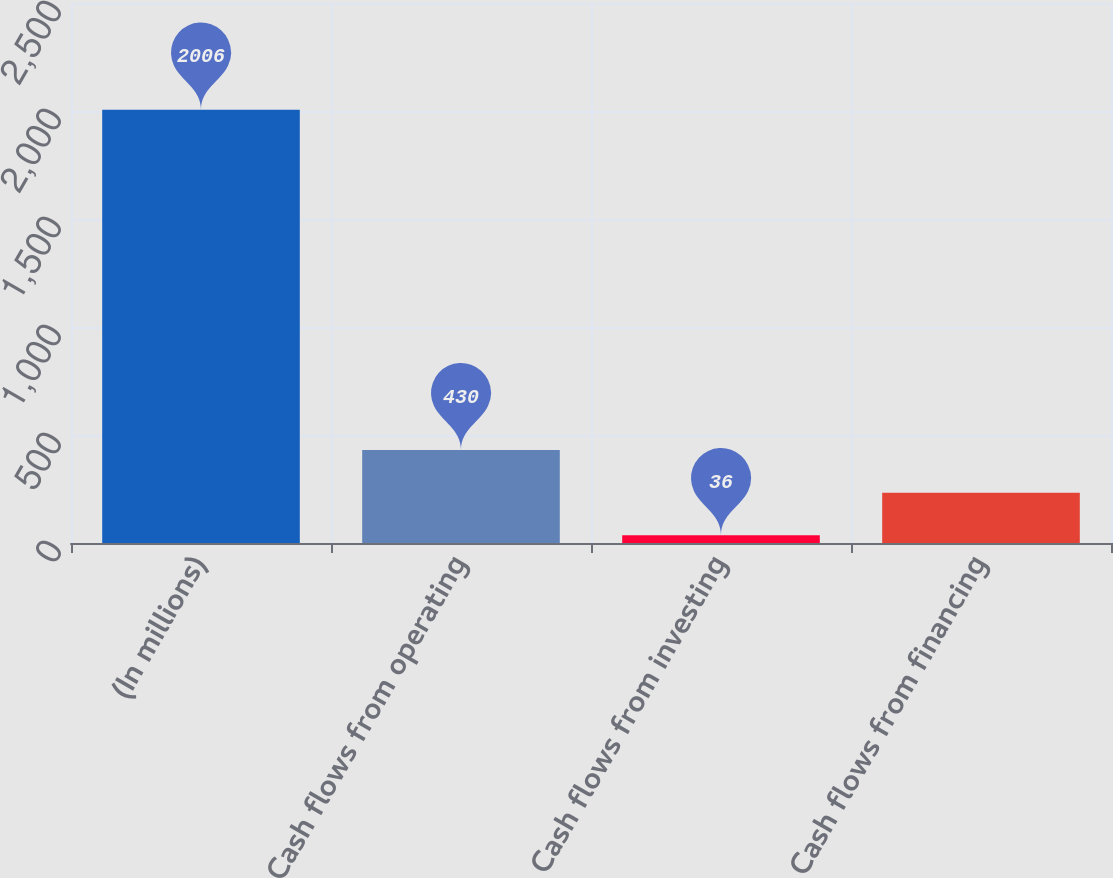<chart> <loc_0><loc_0><loc_500><loc_500><bar_chart><fcel>(In millions)<fcel>Cash flows from operating<fcel>Cash flows from investing<fcel>Cash flows from financing<nl><fcel>2006<fcel>430<fcel>36<fcel>233<nl></chart> 